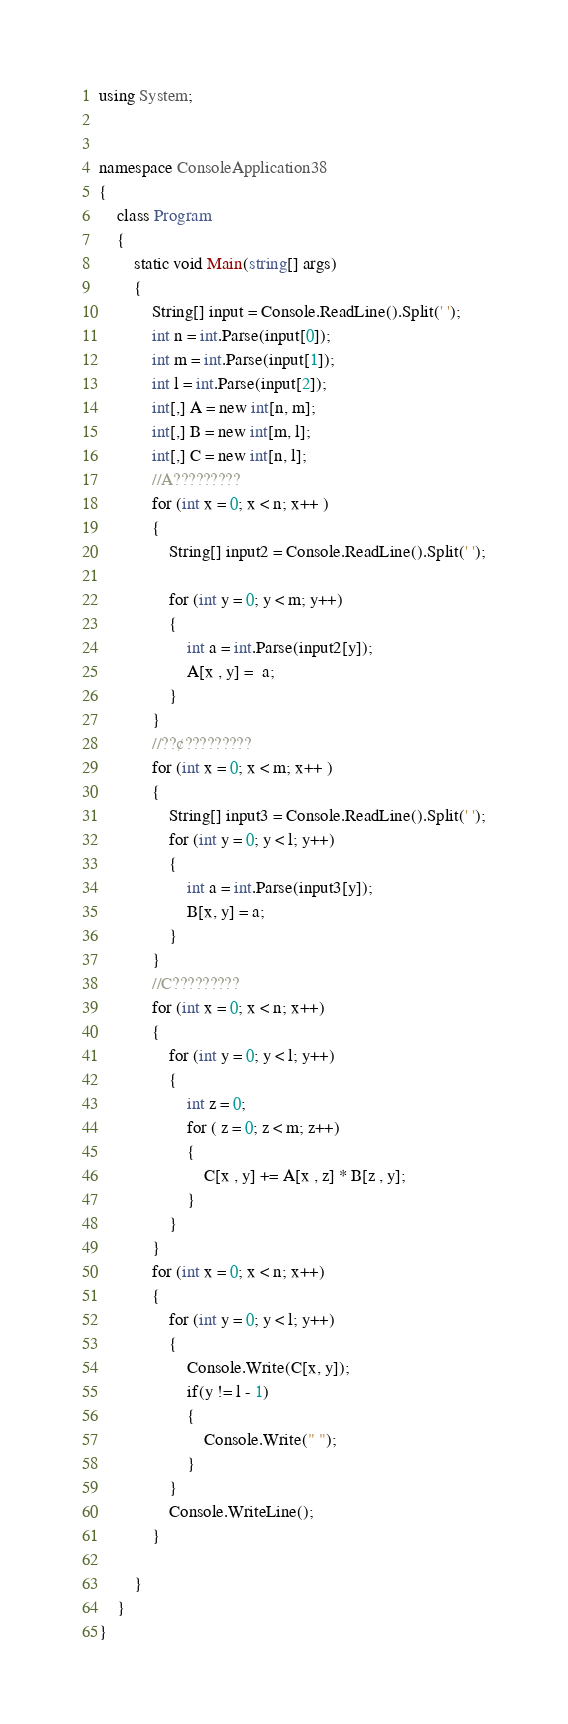<code> <loc_0><loc_0><loc_500><loc_500><_C#_>using System;


namespace ConsoleApplication38
{
    class Program
    {
        static void Main(string[] args)
        {
            String[] input = Console.ReadLine().Split(' ');
            int n = int.Parse(input[0]);
            int m = int.Parse(input[1]);
            int l = int.Parse(input[2]);
            int[,] A = new int[n, m];
            int[,] B = new int[m, l];
            int[,] C = new int[n, l];
            //A?????????
            for (int x = 0; x < n; x++ )
            {
                String[] input2 = Console.ReadLine().Split(' ');
                 
                for (int y = 0; y < m; y++)
                {
                    int a = int.Parse(input2[y]);
                    A[x , y] =  a;
                }
            }
            //??¢?????????
            for (int x = 0; x < m; x++ )
            {
                String[] input3 = Console.ReadLine().Split(' ');
                for (int y = 0; y < l; y++)
                {
                    int a = int.Parse(input3[y]);
                    B[x, y] = a;
                }
            } 
            //C?????????
            for (int x = 0; x < n; x++)
            {
                for (int y = 0; y < l; y++)
                {
                    int z = 0;
                    for ( z = 0; z < m; z++)
                    {
                        C[x , y] += A[x , z] * B[z , y]; 
                    }
                }
            }
            for (int x = 0; x < n; x++)
            {
                for (int y = 0; y < l; y++)
                {
                    Console.Write(C[x, y]);
                    if(y != l - 1)
                    {
                        Console.Write(" ");
                    }
                }
                Console.WriteLine();
            }

        }
    }
}</code> 